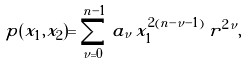Convert formula to latex. <formula><loc_0><loc_0><loc_500><loc_500>p ( x _ { 1 } , x _ { 2 } ) = \sum _ { \nu = 0 } ^ { n - 1 } \, a _ { \nu } \, x _ { 1 } ^ { 2 ( n - \nu - 1 ) } \, r ^ { 2 \nu } ,</formula> 